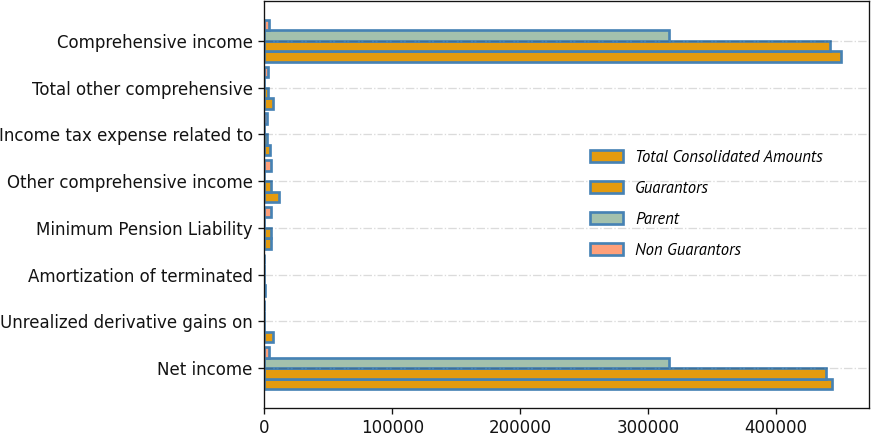Convert chart to OTSL. <chart><loc_0><loc_0><loc_500><loc_500><stacked_bar_chart><ecel><fcel>Net income<fcel>Unrealized derivative gains on<fcel>Amortization of terminated<fcel>Minimum Pension Liability<fcel>Other comprehensive income<fcel>Income tax expense related to<fcel>Total other comprehensive<fcel>Comprehensive income<nl><fcel>Total Consolidated Amounts<fcel>443446<fcel>6677<fcel>336<fcel>4986<fcel>11327<fcel>4306<fcel>7021<fcel>450467<nl><fcel>Guarantors<fcel>438873<fcel>0<fcel>0<fcel>4986<fcel>4986<fcel>1898<fcel>3088<fcel>441961<nl><fcel>Parent<fcel>316617<fcel>0<fcel>0<fcel>0<fcel>0<fcel>0<fcel>0<fcel>316617<nl><fcel>Non Guarantors<fcel>3697<fcel>0<fcel>0<fcel>4986<fcel>4986<fcel>1898<fcel>3088<fcel>3697<nl></chart> 